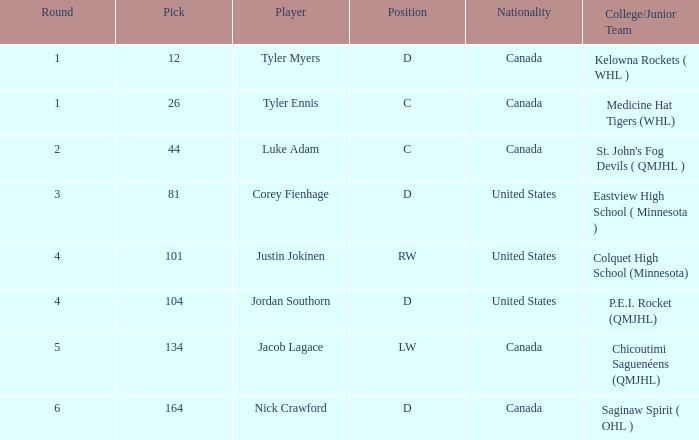What is the nationality of player corey fienhage, who has a pick less than 104? United States. 